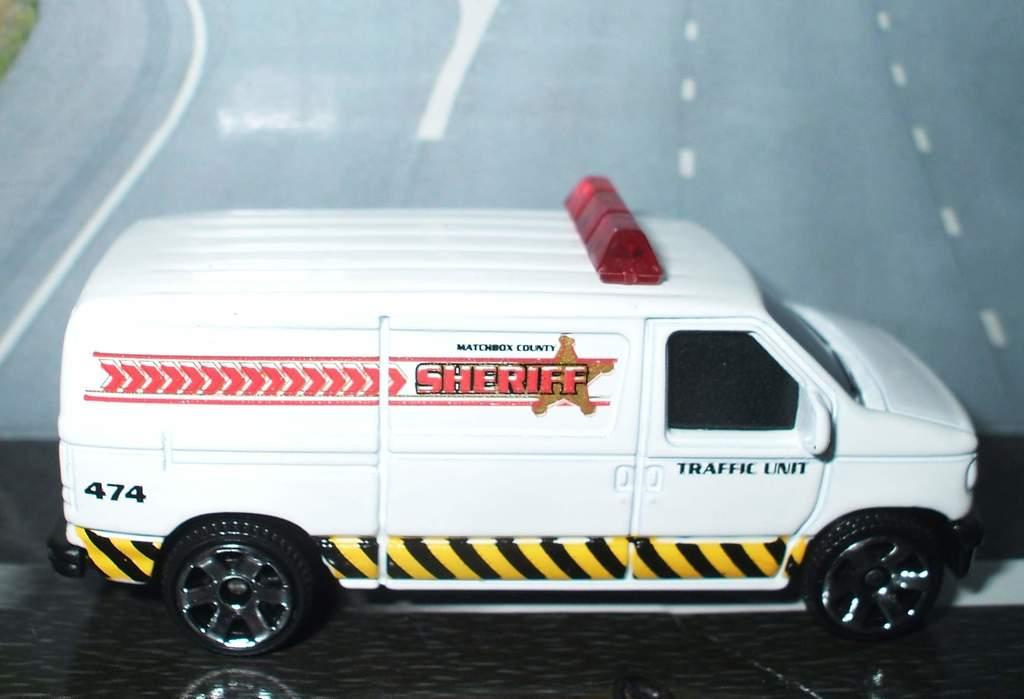<image>
Offer a succinct explanation of the picture presented. A white toy Sheriff van says Traffic Unit on the side. 